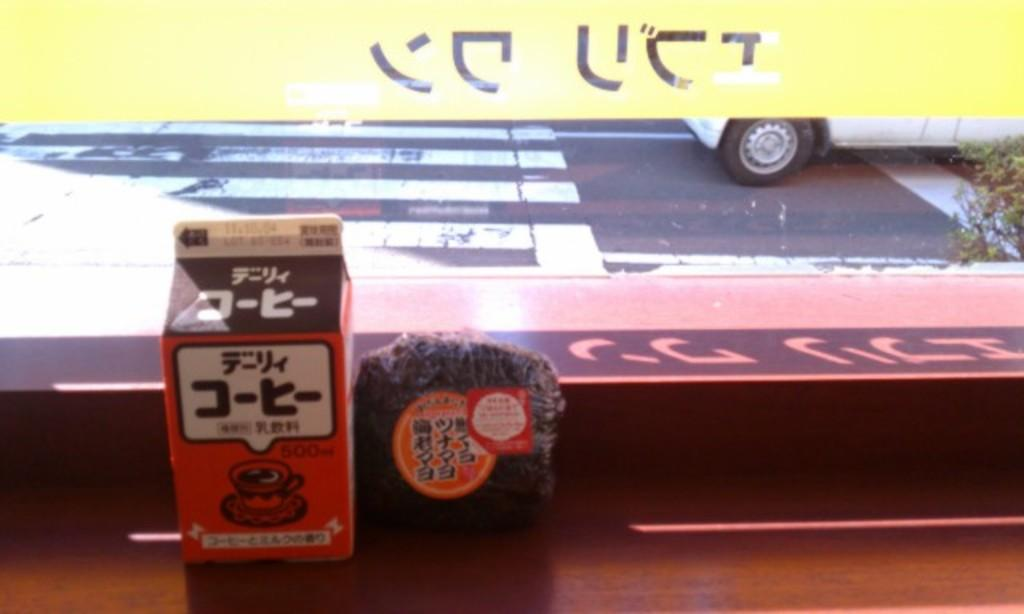What can be seen through the window in the image? There is a road visible behind the window. How many objects are in front of the window? There are two objects in front of the window. What is located on the right side of the image? There is a vehicle on the right side of the image. Can you tell me what type of fiction the lawyer is reading in the image? There is no lawyer or fiction present in the image. Where is the faucet located in the image? There is no faucet present in the image. 